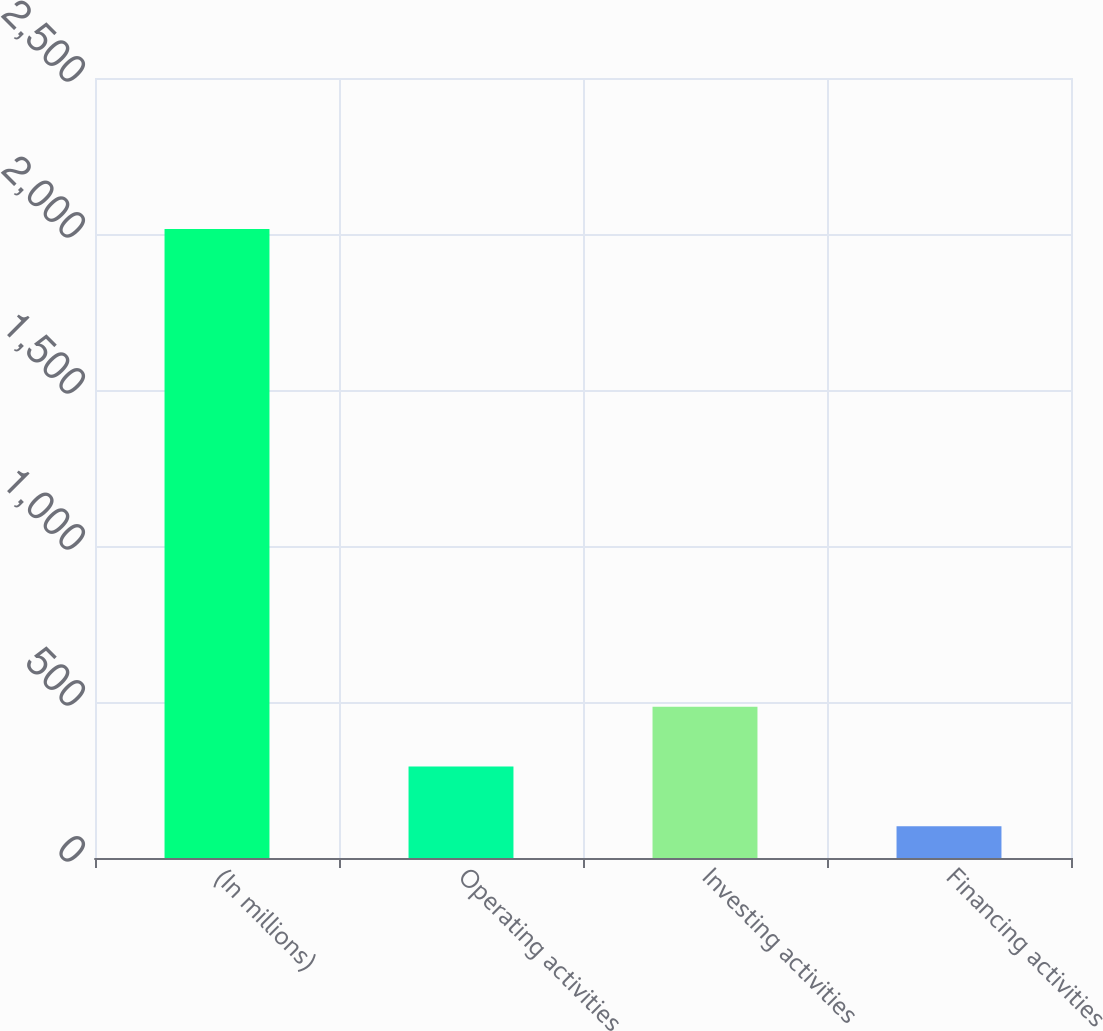Convert chart. <chart><loc_0><loc_0><loc_500><loc_500><bar_chart><fcel>(In millions)<fcel>Operating activities<fcel>Investing activities<fcel>Financing activities<nl><fcel>2016<fcel>293.4<fcel>484.8<fcel>102<nl></chart> 